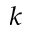<formula> <loc_0><loc_0><loc_500><loc_500>^ { k }</formula> 